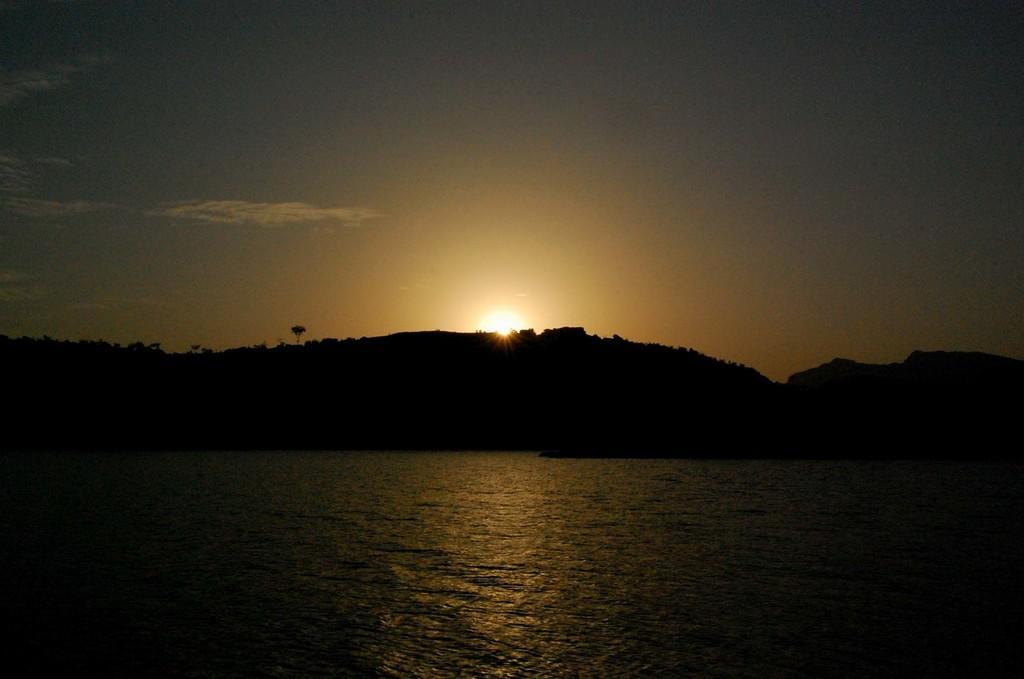Can you describe this image briefly? There is water. In the back there are hills, sky and sun. 